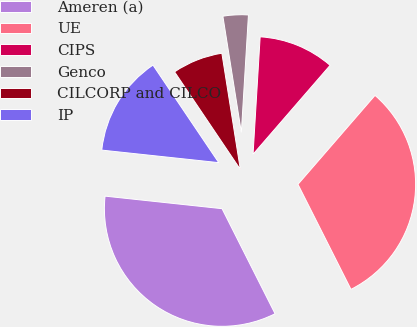Convert chart. <chart><loc_0><loc_0><loc_500><loc_500><pie_chart><fcel>Ameren (a)<fcel>UE<fcel>CIPS<fcel>Genco<fcel>CILCORP and CILCO<fcel>IP<nl><fcel>34.14%<fcel>31.2%<fcel>10.4%<fcel>3.47%<fcel>6.93%<fcel>13.86%<nl></chart> 